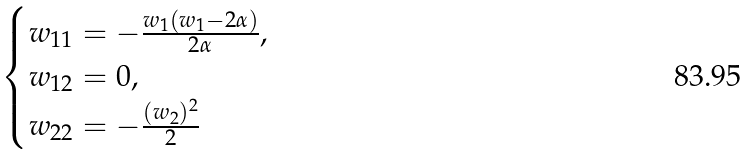Convert formula to latex. <formula><loc_0><loc_0><loc_500><loc_500>\begin{cases} w _ { 1 1 } = - \frac { w _ { 1 } ( w _ { 1 } - 2 \alpha ) } { 2 \alpha } , \\ w _ { 1 2 } = 0 , \\ w _ { 2 2 } = - \frac { ( w _ { 2 } ) ^ { 2 } } { 2 } \end{cases}</formula> 